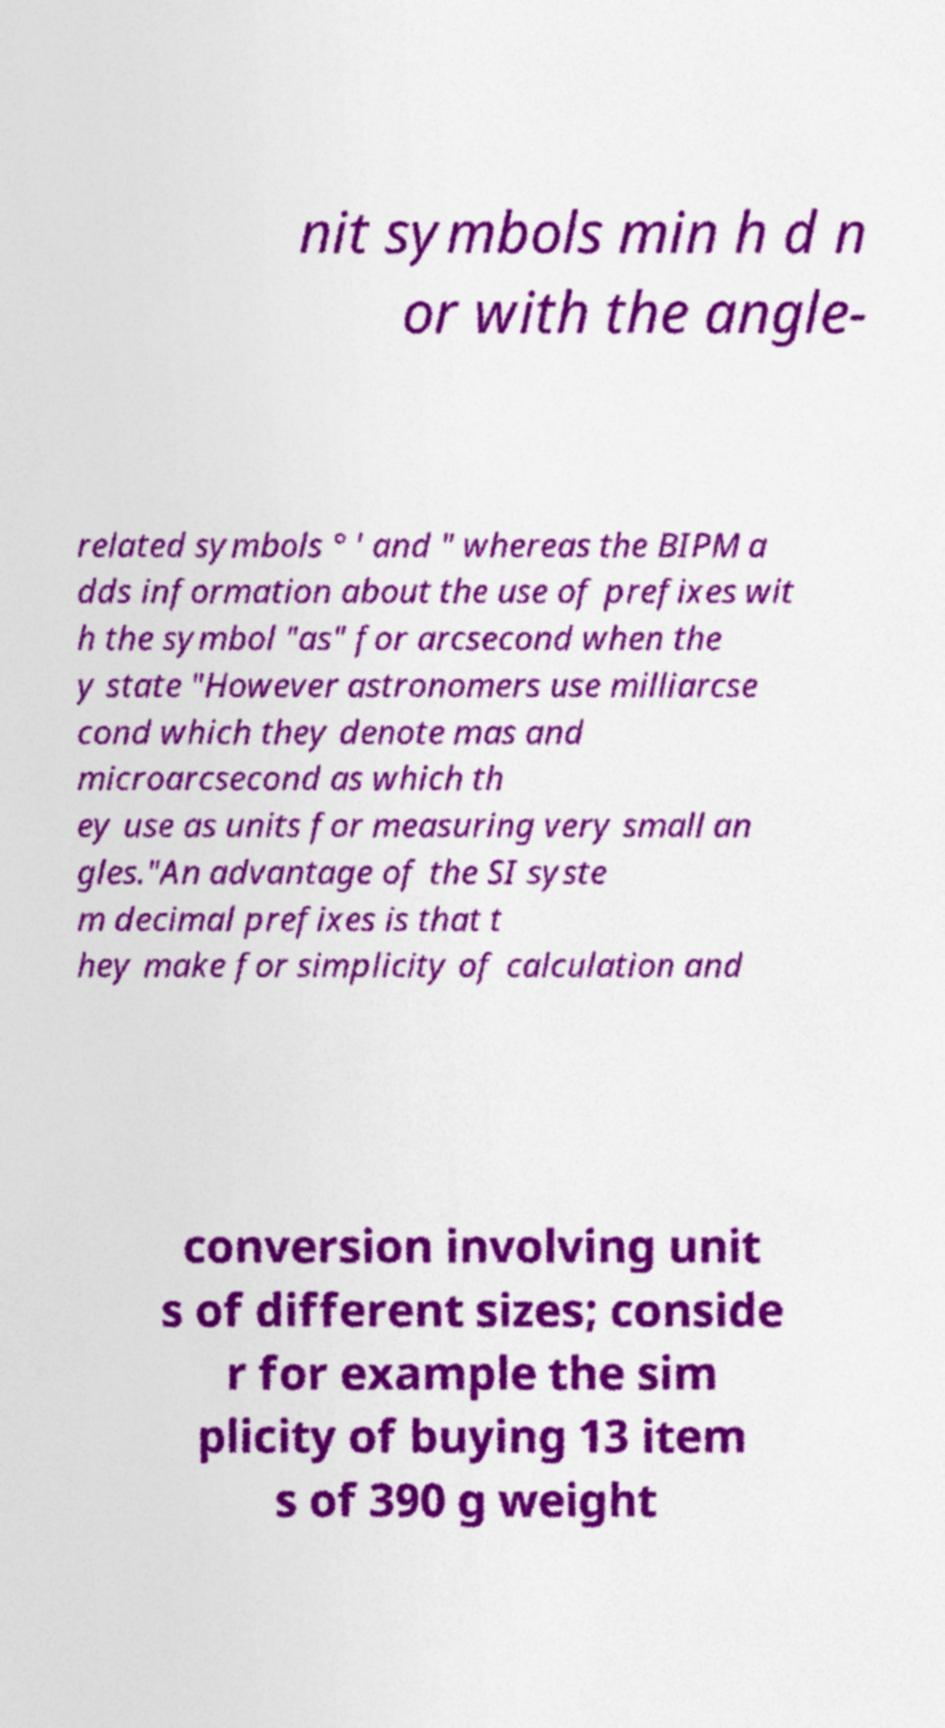Could you assist in decoding the text presented in this image and type it out clearly? nit symbols min h d n or with the angle- related symbols ° ′ and ″ whereas the BIPM a dds information about the use of prefixes wit h the symbol "as" for arcsecond when the y state "However astronomers use milliarcse cond which they denote mas and microarcsecond as which th ey use as units for measuring very small an gles."An advantage of the SI syste m decimal prefixes is that t hey make for simplicity of calculation and conversion involving unit s of different sizes; conside r for example the sim plicity of buying 13 item s of 390 g weight 